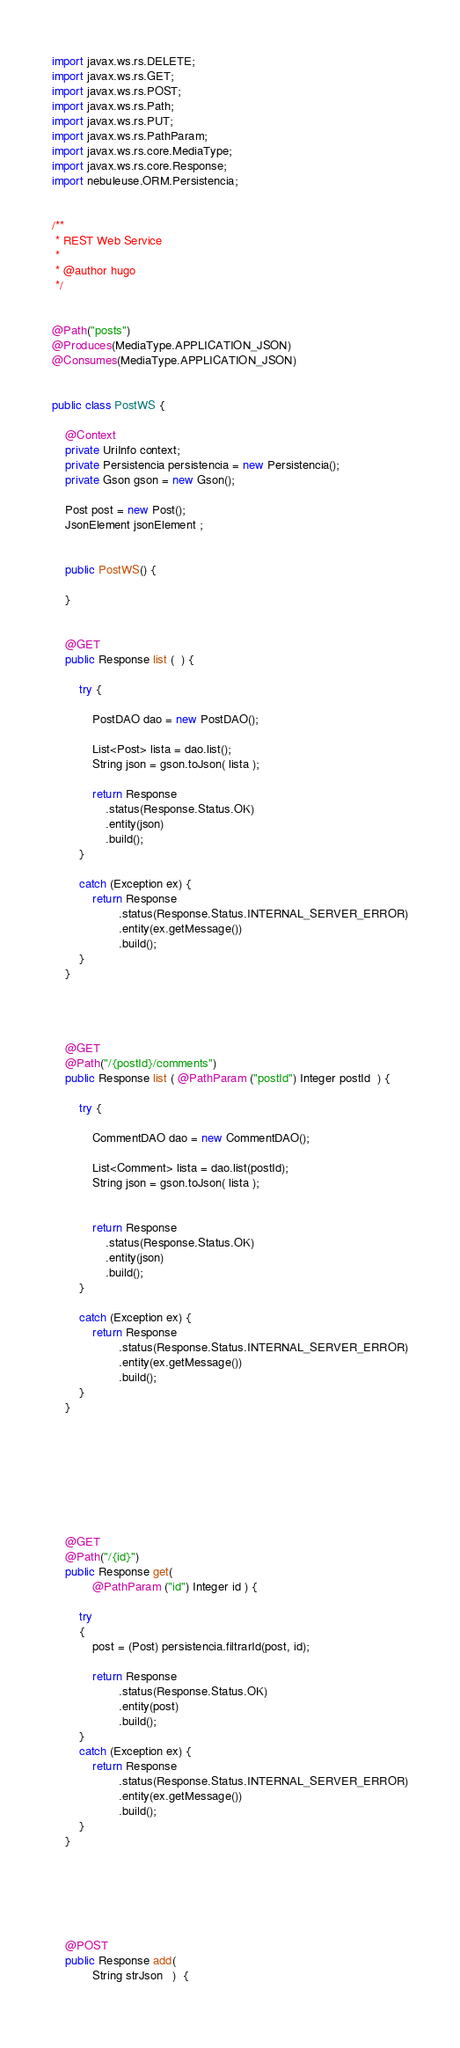Convert code to text. <code><loc_0><loc_0><loc_500><loc_500><_Java_>import javax.ws.rs.DELETE;
import javax.ws.rs.GET;
import javax.ws.rs.POST;
import javax.ws.rs.Path;
import javax.ws.rs.PUT;
import javax.ws.rs.PathParam;
import javax.ws.rs.core.MediaType;
import javax.ws.rs.core.Response;
import nebuleuse.ORM.Persistencia;


/**
 * REST Web Service
 *
 * @author hugo
 */


@Path("posts")
@Produces(MediaType.APPLICATION_JSON)
@Consumes(MediaType.APPLICATION_JSON)


public class PostWS {

    @Context
    private UriInfo context;
    private Persistencia persistencia = new Persistencia();   
    private Gson gson = new Gson();    
    
    Post post = new Post();   
    JsonElement jsonElement ;


    public PostWS() {
      
    }

    
    @GET    
    public Response list (  ) {

        try {               
                        
            PostDAO dao = new PostDAO();

            List<Post> lista = dao.list();                
            String json = gson.toJson( lista );        
                
            return Response
                .status(Response.Status.OK)
                .entity(json)
                .build();                                         
        }     
        
        catch (Exception ex) {
            return Response
                    .status(Response.Status.INTERNAL_SERVER_ERROR)
                    .entity(ex.getMessage())
                    .build();                                        
        }      
    }    
    
    
        
    
    @GET    
    @Path("/{postId}/comments")
    public Response list ( @PathParam ("postId") Integer postId  ) {

        try {
                        
            CommentDAO dao = new CommentDAO();

            List<Comment> lista = dao.list(postId);                
            String json = gson.toJson( lista );        

            
            return Response
                .status(Response.Status.OK)
                .entity(json)
                .build();                                         
        }     
        
        catch (Exception ex) {
            return Response
                    .status(Response.Status.INTERNAL_SERVER_ERROR)
                    .entity(ex.getMessage())
                    .build();                                        
        }      
    }    
    
        
    
    
    
    
    
    
    @GET
    @Path("/{id}")
    public Response get(                 
            @PathParam ("id") Integer id ) {
                     
        try 
        {      
            post = (Post) persistencia.filtrarId(post, id);  

            return Response
                    .status(Response.Status.OK)
                    .entity(post)                        
                    .build();       
        }     
        catch (Exception ex) {
            return Response
                    .status(Response.Status.INTERNAL_SERVER_ERROR)
                    .entity(ex.getMessage())                    
                    .build();                                        
        }  
    }    
      
       
    
    
    
 
    @POST
    public Response add(             
            String strJson   )  {            
       </code> 